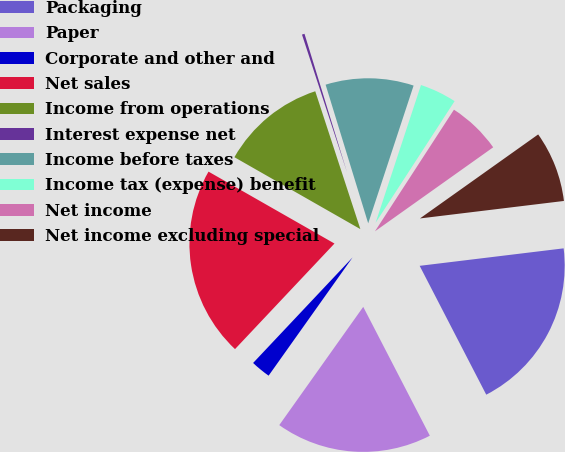<chart> <loc_0><loc_0><loc_500><loc_500><pie_chart><fcel>Packaging<fcel>Paper<fcel>Corporate and other and<fcel>Net sales<fcel>Income from operations<fcel>Interest expense net<fcel>Income before taxes<fcel>Income tax (expense) benefit<fcel>Net income<fcel>Net income excluding special<nl><fcel>19.33%<fcel>17.42%<fcel>2.2%<fcel>21.23%<fcel>11.71%<fcel>0.29%<fcel>9.81%<fcel>4.1%<fcel>6.0%<fcel>7.91%<nl></chart> 